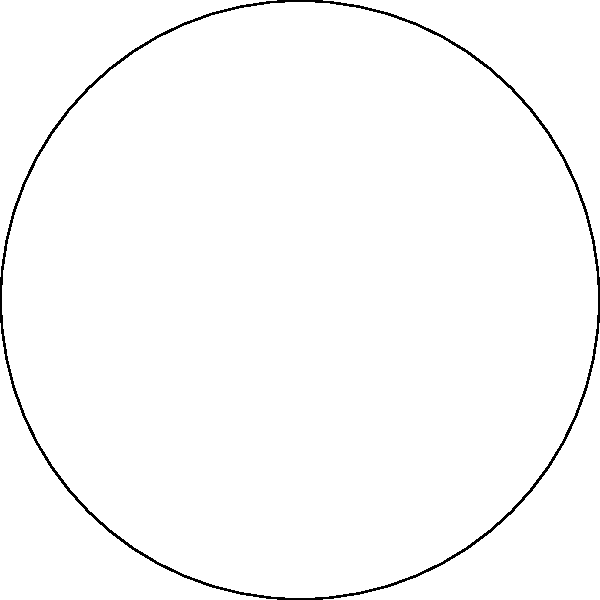In the Poincaré disk model of hyperbolic geometry shown above, three hyperbolic lines form a triangle ABC. Which of the following statements is true about the sum of the interior angles of this hyperbolic triangle? To understand this concept, let's break it down step-by-step:

1. In Euclidean geometry, the sum of interior angles of a triangle is always 180°.

2. However, in hyperbolic geometry, this rule doesn't hold true.

3. The Poincaré disk model is a way to represent hyperbolic geometry in a 2D Euclidean plane.

4. In this model, hyperbolic lines are represented as arcs of circles that intersect the boundary circle perpendicularly.

5. A key property of hyperbolic geometry is that the sum of interior angles of a triangle is always less than 180°.

6. This is because parallel lines in hyperbolic geometry diverge, causing angles to appear smaller than they would in Euclidean geometry.

7. The larger the hyperbolic triangle (relative to the Poincaré disk), the smaller the sum of its interior angles will be.

8. In the given diagram, we can see that the triangle ABC takes up a significant portion of the disk, indicating that its angles would sum to considerably less than 180°.

Therefore, in hyperbolic geometry, and specifically in this Poincaré disk model, the sum of the interior angles of triangle ABC is less than 180°.
Answer: Less than 180° 